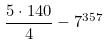<formula> <loc_0><loc_0><loc_500><loc_500>\frac { 5 \cdot 1 4 0 } { 4 } - 7 ^ { 3 5 7 }</formula> 